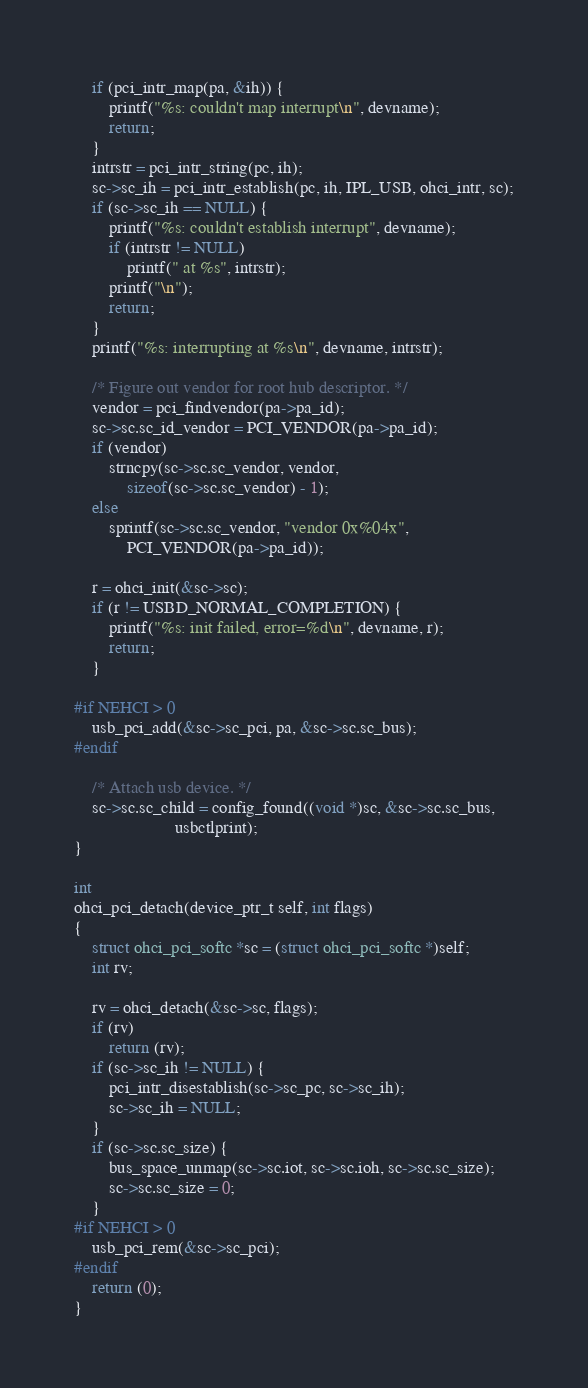Convert code to text. <code><loc_0><loc_0><loc_500><loc_500><_C_>	if (pci_intr_map(pa, &ih)) {
		printf("%s: couldn't map interrupt\n", devname);
		return;
	}
	intrstr = pci_intr_string(pc, ih);
	sc->sc_ih = pci_intr_establish(pc, ih, IPL_USB, ohci_intr, sc);
	if (sc->sc_ih == NULL) {
		printf("%s: couldn't establish interrupt", devname);
		if (intrstr != NULL)
			printf(" at %s", intrstr);
		printf("\n");
		return;
	}
	printf("%s: interrupting at %s\n", devname, intrstr);

	/* Figure out vendor for root hub descriptor. */
	vendor = pci_findvendor(pa->pa_id);
	sc->sc.sc_id_vendor = PCI_VENDOR(pa->pa_id);
	if (vendor)
		strncpy(sc->sc.sc_vendor, vendor, 
			sizeof(sc->sc.sc_vendor) - 1);
	else
		sprintf(sc->sc.sc_vendor, "vendor 0x%04x", 
			PCI_VENDOR(pa->pa_id));
	
	r = ohci_init(&sc->sc);
	if (r != USBD_NORMAL_COMPLETION) {
		printf("%s: init failed, error=%d\n", devname, r);
		return;
	}

#if NEHCI > 0
	usb_pci_add(&sc->sc_pci, pa, &sc->sc.sc_bus);
#endif

	/* Attach usb device. */
	sc->sc.sc_child = config_found((void *)sc, &sc->sc.sc_bus,
				       usbctlprint);
}

int
ohci_pci_detach(device_ptr_t self, int flags)
{
	struct ohci_pci_softc *sc = (struct ohci_pci_softc *)self;
	int rv;

	rv = ohci_detach(&sc->sc, flags);
	if (rv)
		return (rv);
	if (sc->sc_ih != NULL) {
		pci_intr_disestablish(sc->sc_pc, sc->sc_ih);
		sc->sc_ih = NULL;
	}
	if (sc->sc.sc_size) {
		bus_space_unmap(sc->sc.iot, sc->sc.ioh, sc->sc.sc_size);
		sc->sc.sc_size = 0;
	}
#if NEHCI > 0
	usb_pci_rem(&sc->sc_pci);
#endif
	return (0);
}
</code> 